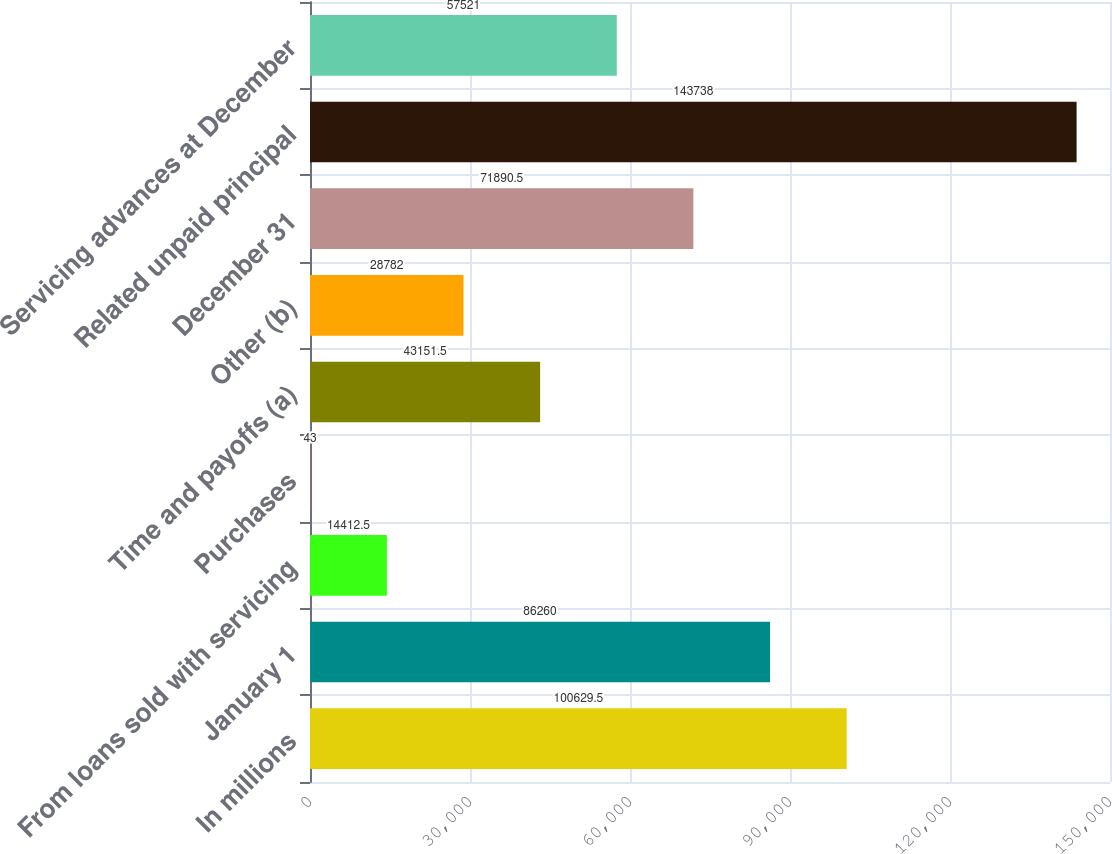Convert chart to OTSL. <chart><loc_0><loc_0><loc_500><loc_500><bar_chart><fcel>In millions<fcel>January 1<fcel>From loans sold with servicing<fcel>Purchases<fcel>Time and payoffs (a)<fcel>Other (b)<fcel>December 31<fcel>Related unpaid principal<fcel>Servicing advances at December<nl><fcel>100630<fcel>86260<fcel>14412.5<fcel>43<fcel>43151.5<fcel>28782<fcel>71890.5<fcel>143738<fcel>57521<nl></chart> 